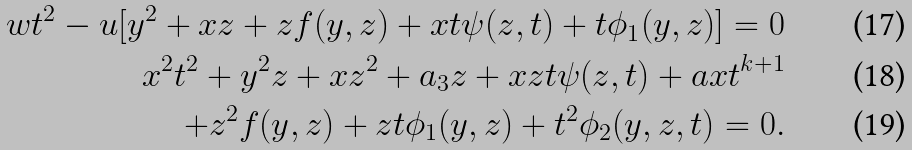<formula> <loc_0><loc_0><loc_500><loc_500>w t ^ { 2 } - u [ y ^ { 2 } + x z + z f ( y , z ) + x t \psi ( z , t ) + t \phi _ { 1 } ( y , z ) ] = 0 \\ x ^ { 2 } t ^ { 2 } + y ^ { 2 } z + x z ^ { 2 } + a _ { 3 } z + x z t \psi ( z , t ) + a x t ^ { k + 1 } \\ + z ^ { 2 } f ( y , z ) + z t \phi _ { 1 } ( y , z ) + t ^ { 2 } \phi _ { 2 } ( y , z , t ) = 0 .</formula> 